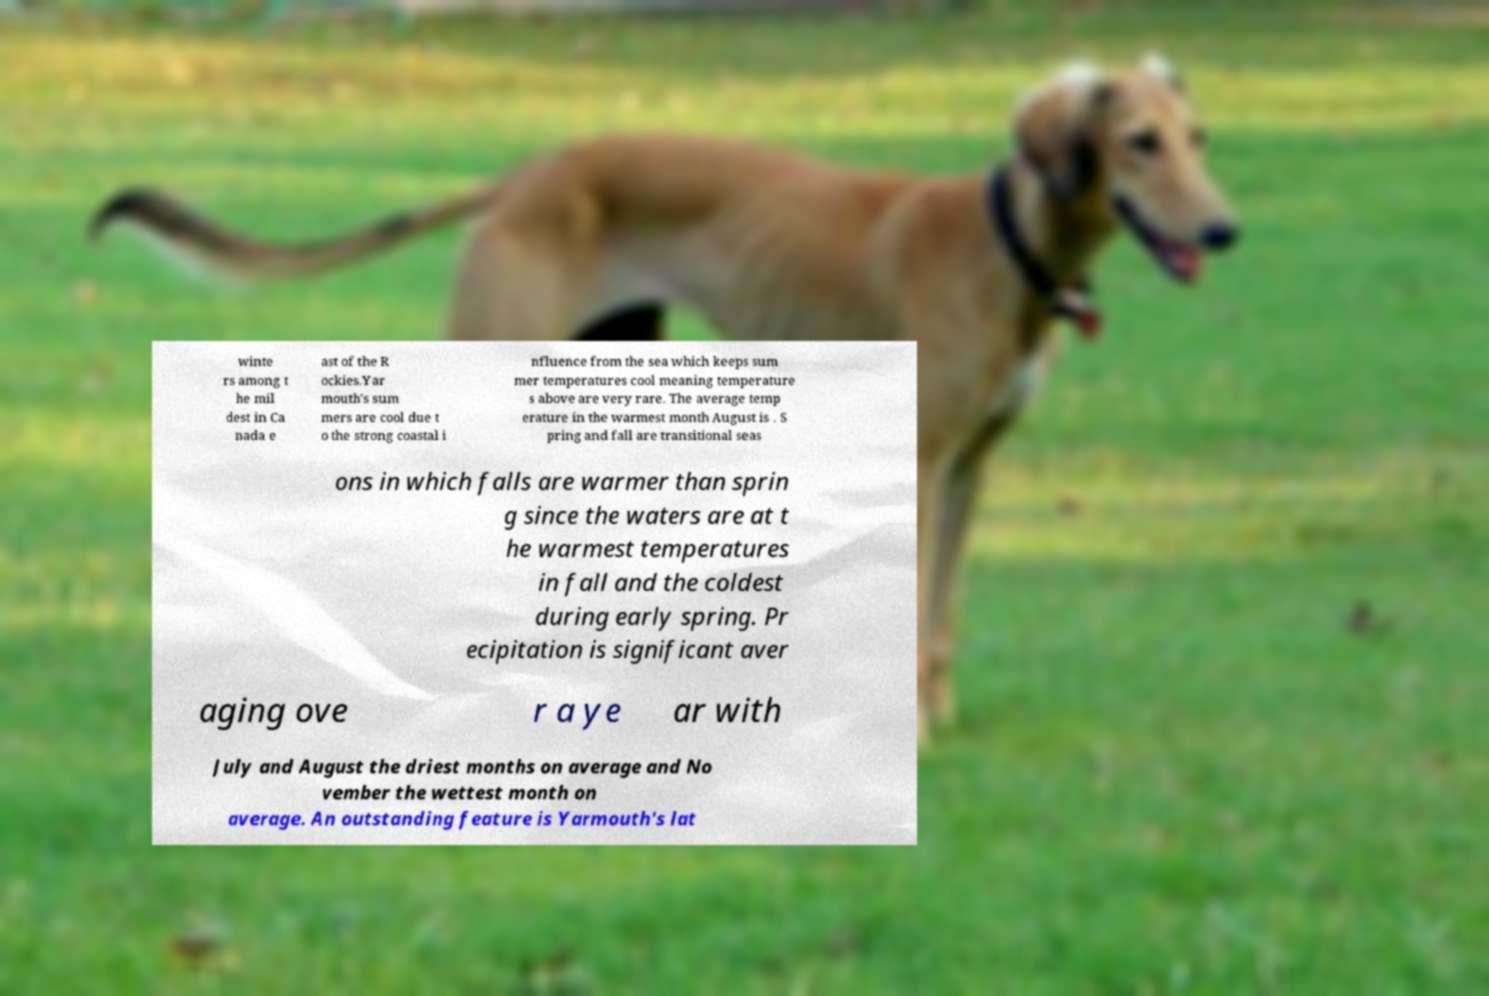I need the written content from this picture converted into text. Can you do that? winte rs among t he mil dest in Ca nada e ast of the R ockies.Yar mouth's sum mers are cool due t o the strong coastal i nfluence from the sea which keeps sum mer temperatures cool meaning temperature s above are very rare. The average temp erature in the warmest month August is . S pring and fall are transitional seas ons in which falls are warmer than sprin g since the waters are at t he warmest temperatures in fall and the coldest during early spring. Pr ecipitation is significant aver aging ove r a ye ar with July and August the driest months on average and No vember the wettest month on average. An outstanding feature is Yarmouth's lat 